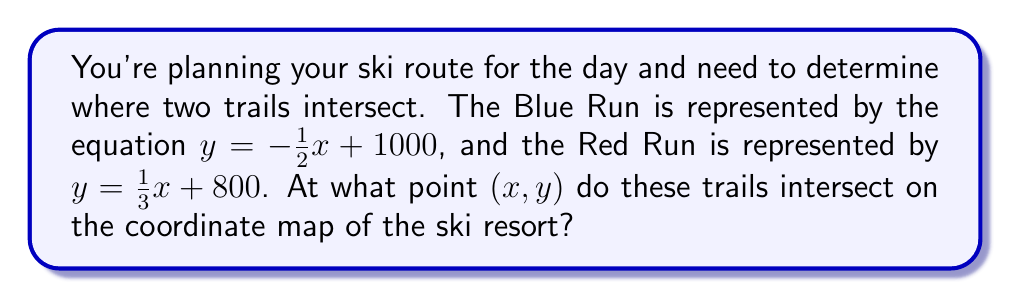Help me with this question. To find the intersection point of the two ski trails, we need to solve the system of linear equations:

$$\begin{cases}
y = -\frac{1}{2}x + 1000 \quad \text{(Blue Run)} \\
y = \frac{1}{3}x + 800 \quad \text{(Red Run)}
\end{cases}$$

Step 1: Set the equations equal to each other since they intersect at a point where y-values are the same.
$$-\frac{1}{2}x + 1000 = \frac{1}{3}x + 800$$

Step 2: Multiply both sides by 6 to eliminate fractions.
$$-3x + 6000 = 2x + 4800$$

Step 3: Subtract 2x from both sides.
$$-5x + 6000 = 4800$$

Step 4: Subtract 4800 from both sides.
$$-5x + 1200 = 0$$

Step 5: Add 5x to both sides.
$$1200 = 5x$$

Step 6: Divide both sides by 5.
$$x = 240$$

Step 7: Substitute x = 240 into either of the original equations. Let's use the Blue Run equation:
$$y = -\frac{1}{2}(240) + 1000 = -120 + 1000 = 880$$

Therefore, the intersection point is (240, 880).
Answer: (240, 880) 